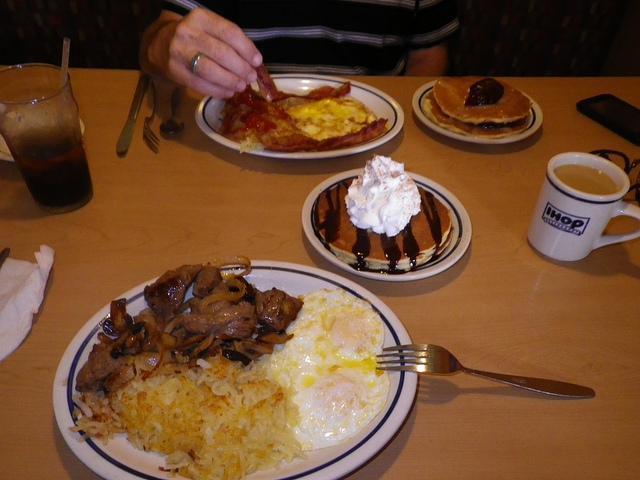What food on the table contains the highest amount of fat?
Pick the correct solution from the four options below to address the question.
Options: Bacon, rice, pancake, egg. Bacon. 